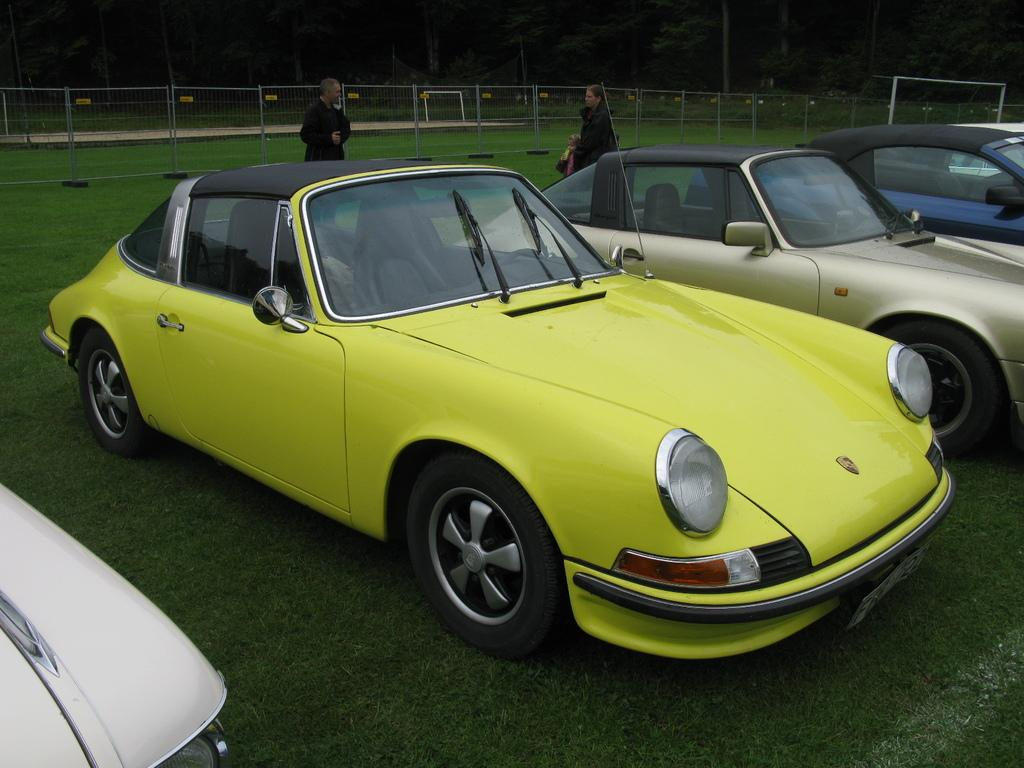What can be seen on the ground in the image? There are many cars parked on the ground in the image. Are there any people visible in the image? Yes, there are two people standing at the back in the image. What type of leather is being used to make the eggnog in the image? There is no eggnog or leather present in the image; it features parked cars and people standing at the back. 